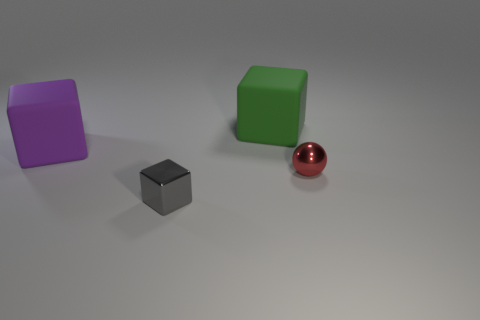Is there a big green thing that has the same shape as the gray thing?
Your answer should be compact. Yes. There is a small cube; does it have the same color as the matte thing that is left of the green cube?
Offer a very short reply. No. Is there a cyan cube of the same size as the gray object?
Your answer should be compact. No. Do the tiny sphere and the big purple cube left of the green block have the same material?
Keep it short and to the point. No. Are there more tiny shiny things than green rubber cubes?
Ensure brevity in your answer.  Yes. How many balls are blue metallic things or red metal objects?
Give a very brief answer. 1. The tiny sphere is what color?
Provide a succinct answer. Red. Is the size of the object in front of the tiny red ball the same as the matte block that is on the right side of the purple matte cube?
Provide a succinct answer. No. Are there fewer green matte objects than tiny blue matte balls?
Your answer should be very brief. No. There is a metallic sphere; what number of things are behind it?
Ensure brevity in your answer.  2. 